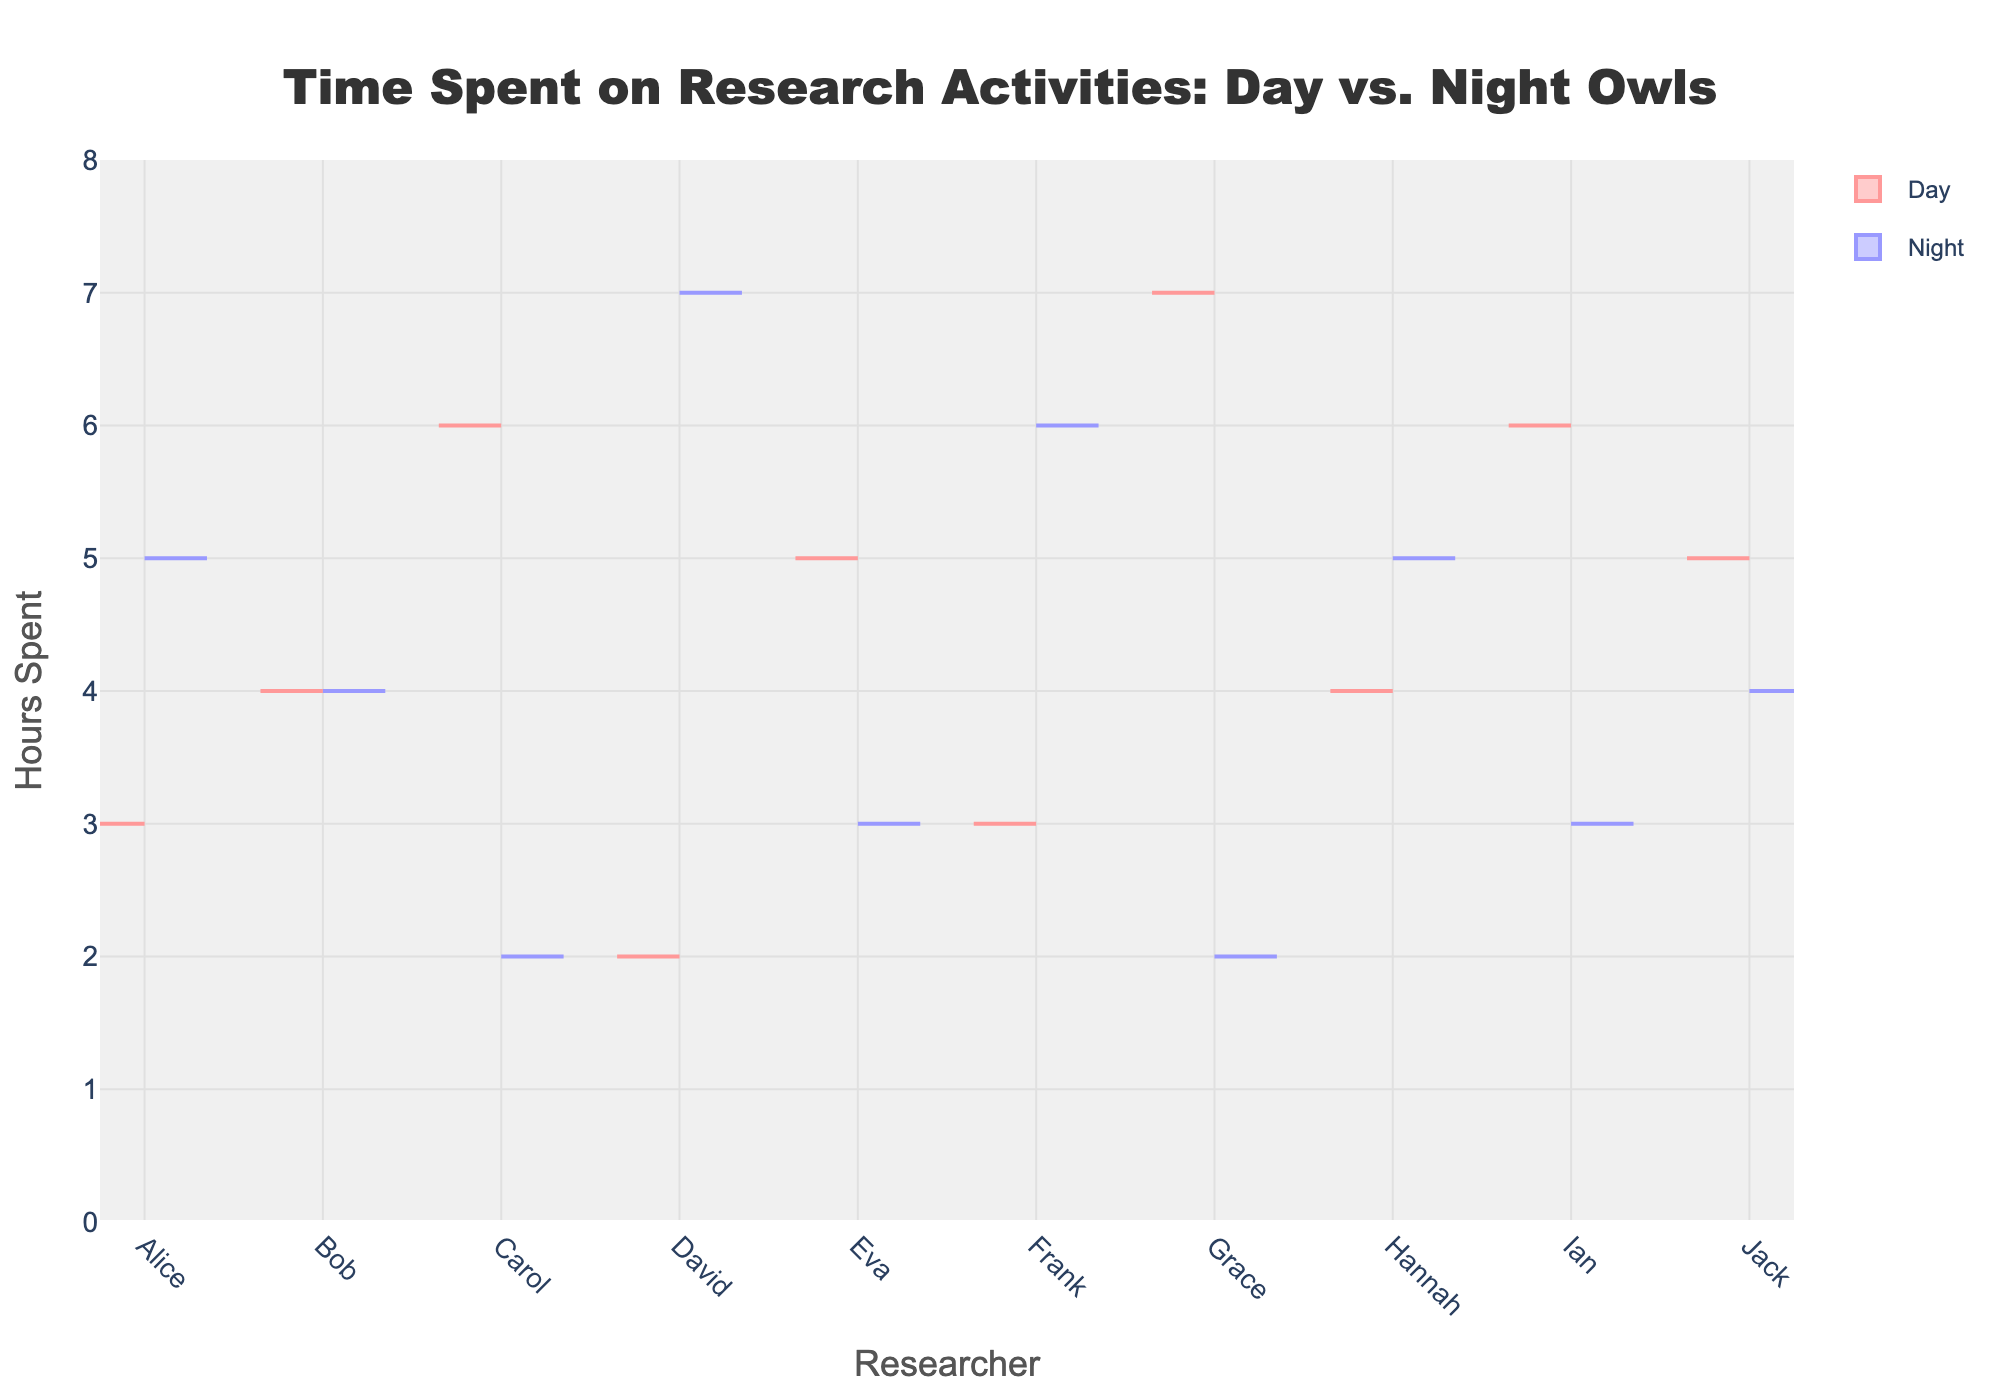What is the title of the chart? The title of the chart is displayed at the top center of the figure, styled in large font. It reads as "Time Spent on Research Activities: Day vs. Night Owls".
Answer: Time Spent on Research Activities: Day vs. Night Owls Which researcher spent the most hours during the day? We need to look at the maximum of the distribution on the 'Day' side of the chart. Grace spent the most hours with 7 hours during the day.
Answer: Grace How many researchers spent more hours at night than during the day? We need to compare the hours spent during the day and night for each researcher. Alice, David, Frank, and Hannah spent more hours at night than during the day.
Answer: 4 What is the range of hours spent on research at night? We need to find the minimum and maximum values of hours spent on research at night. The minimum is 2 (Carol and Grace) and the maximum is 7 (David). So the range is 7 - 2 = 5 hours.
Answer: 5 hours What is the average number of hours spent on research during the day for all researchers? Add the hours spent during the day for all researchers and divide by the number of researchers. (3 + 4 + 6 + 2 + 5 + 3 + 7 + 4 + 6 + 5) / 10 = 45 / 10 = 4.5
Answer: 4.5 Which researcher has balanced hours between day and night? To find balanced hours, compare the day and night hours for each researcher. Bob has equal hours (4 + 4).
Answer: Bob Who spent the least amount of time on research during the day? We need to find the minimum value from the 'Day' part of the chart. David spent the least amount with 2 hours.
Answer: David Which side (day or night) has a higher median hours spent on research? Calculate the median for both 'Day' and 'Night' distributions. Day: [2, 3, 3, 4, 4, 5, 5, 6, 6, 7] - Median is 4.5. Night: [2, 2, 3, 3, 4, 4, 5, 5, 6, 7] - Median is 4. The 'Day' side has a slightly higher median.
Answer: Day What is the total number of hours spent on research by all researchers combined? Add up all the hours spent during both day and night for all researchers: (3+4+6+2+5+3+7+4+6+5) + (5+4+2+7+3+6+2+5+3+4) = 45 + 41 = 86.
Answer: 86 Which researcher has the highest difference in hours spent between day and night? Calculate the difference for each researcher: Alice (2), Bob (0), Carol (4), David (5), Eva (2), Frank (3), Grace (5), Hannah (1), Ian (3), Jack (1). David and Grace both have the highest difference of 5 hours.
Answer: David and Grace 